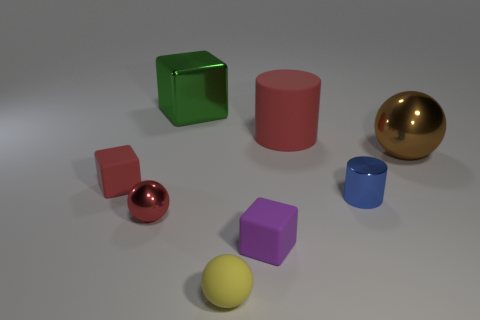Do the brown object and the block that is to the left of the green shiny block have the same material? The brown object, which appears to be a sphere, and the block to the left of the green shiny block do not have the same material. The brown sphere has a matte finish with no reflections, indicating it's probably made of a dull or non-reflective material. In contrast, the block beside the green one has a slightly reflective surface, suggesting it may be made of a material with a bit of glossiness, though it's not as shiny as the green block. 